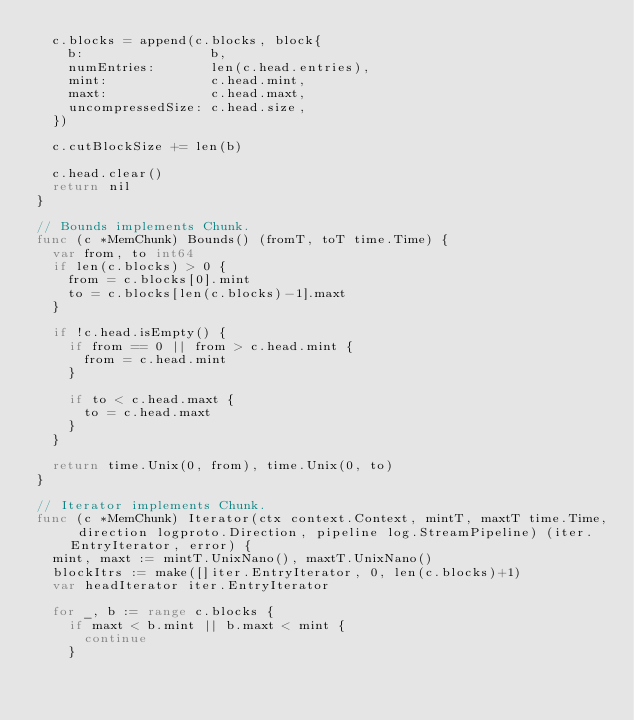<code> <loc_0><loc_0><loc_500><loc_500><_Go_>	c.blocks = append(c.blocks, block{
		b:                b,
		numEntries:       len(c.head.entries),
		mint:             c.head.mint,
		maxt:             c.head.maxt,
		uncompressedSize: c.head.size,
	})

	c.cutBlockSize += len(b)

	c.head.clear()
	return nil
}

// Bounds implements Chunk.
func (c *MemChunk) Bounds() (fromT, toT time.Time) {
	var from, to int64
	if len(c.blocks) > 0 {
		from = c.blocks[0].mint
		to = c.blocks[len(c.blocks)-1].maxt
	}

	if !c.head.isEmpty() {
		if from == 0 || from > c.head.mint {
			from = c.head.mint
		}

		if to < c.head.maxt {
			to = c.head.maxt
		}
	}

	return time.Unix(0, from), time.Unix(0, to)
}

// Iterator implements Chunk.
func (c *MemChunk) Iterator(ctx context.Context, mintT, maxtT time.Time, direction logproto.Direction, pipeline log.StreamPipeline) (iter.EntryIterator, error) {
	mint, maxt := mintT.UnixNano(), maxtT.UnixNano()
	blockItrs := make([]iter.EntryIterator, 0, len(c.blocks)+1)
	var headIterator iter.EntryIterator

	for _, b := range c.blocks {
		if maxt < b.mint || b.maxt < mint {
			continue
		}</code> 